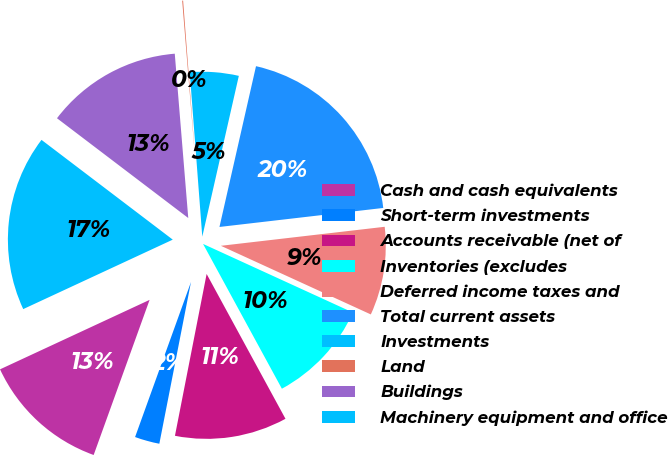Convert chart. <chart><loc_0><loc_0><loc_500><loc_500><pie_chart><fcel>Cash and cash equivalents<fcel>Short-term investments<fcel>Accounts receivable (net of<fcel>Inventories (excludes<fcel>Deferred income taxes and<fcel>Total current assets<fcel>Investments<fcel>Land<fcel>Buildings<fcel>Machinery equipment and office<nl><fcel>12.57%<fcel>2.43%<fcel>11.01%<fcel>10.23%<fcel>8.67%<fcel>19.6%<fcel>4.77%<fcel>0.09%<fcel>13.35%<fcel>17.26%<nl></chart> 